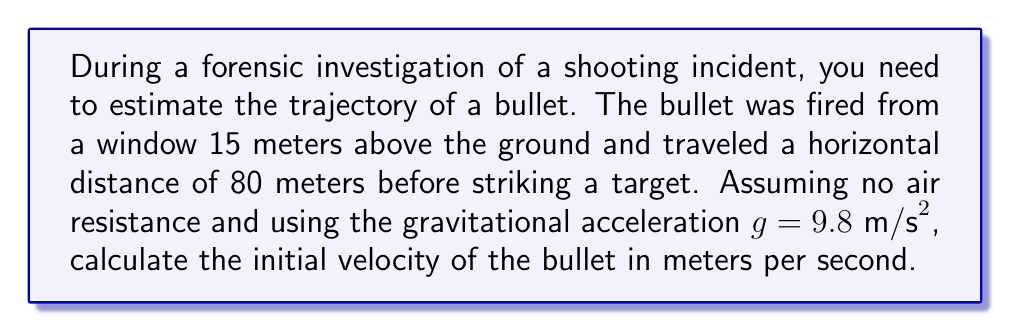Teach me how to tackle this problem. To solve this problem, we'll use the equations of motion for projectile motion:

1) Horizontal motion: $x = v_0 \cos(\theta) t$
2) Vertical motion: $y = v_0 \sin(\theta) t - \frac{1}{2}gt^2$

Where:
$x$ is the horizontal distance (80 m)
$y$ is the vertical distance (-15 m, as the bullet drops 15 m)
$v_0$ is the initial velocity (what we're solving for)
$\theta$ is the angle of launch
$t$ is the time of flight
$g$ is the gravitational acceleration (9.8 m/s²)

Step 1: Express time in terms of horizontal motion
$$t = \frac{x}{v_0 \cos(\theta)}$$

Step 2: Substitute this into the vertical motion equation
$$-15 = v_0 \sin(\theta) \cdot \frac{x}{v_0 \cos(\theta)} - \frac{1}{2}g\left(\frac{x}{v_0 \cos(\theta)}\right)^2$$

Step 3: Simplify
$$-15 = x \tan(\theta) - \frac{gx^2}{2v_0^2 \cos^2(\theta)}$$

Step 4: Rearrange to isolate $v_0$
$$v_0^2 = \frac{gx^2}{2\cos^2(\theta)(x \tan(\theta) + 15)}$$

Step 5: To minimize $v_0$, we need to maximize $\cos^2(\theta)(x \tan(\theta) + 15)$. This occurs when $\theta = 45°$.

Step 6: Substitute known values
$$v_0^2 = \frac{9.8 \cdot 80^2}{2 \cdot (0.5)^2 \cdot (80 + 15)} = 1045.71$$

Step 7: Take the square root
$$v_0 = \sqrt{1045.71} \approx 32.34 \text{ m/s}$$
Answer: 32.34 m/s 